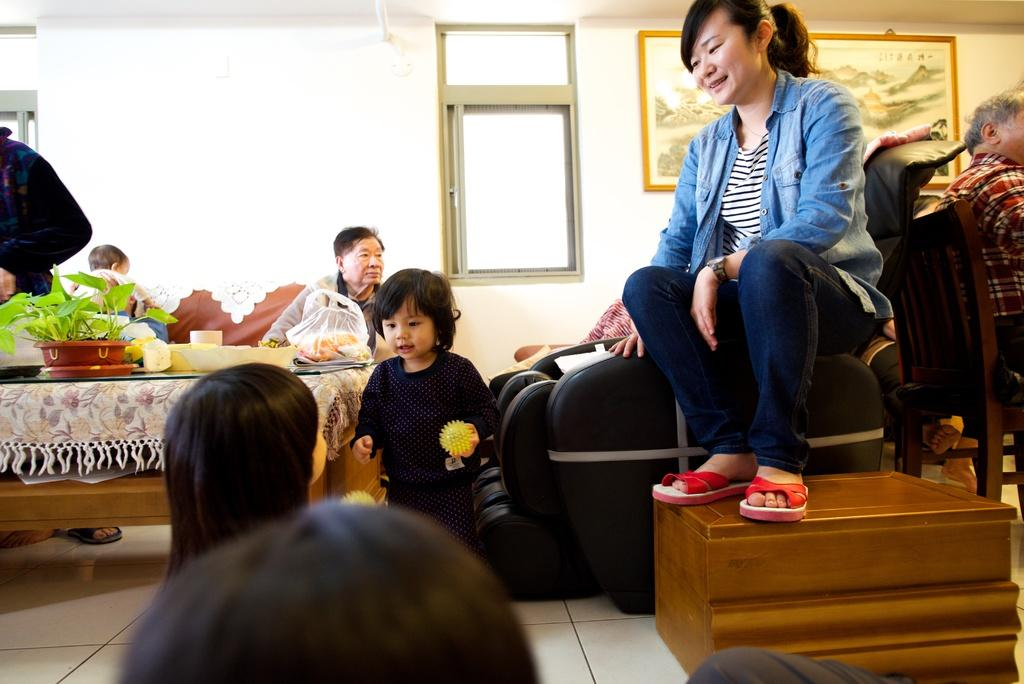What are the people in the image doing? There is a group of people sitting in the image. What is present in the image besides the people? There is a table in the image. What can be seen on the table? There is a flower vase on the table, and there are objects on the table. What is attached to the wall in the image? There are frames attached to the wall. What type of sheep can be seen grazing in the image? There are no sheep present in the image; it features a group of people sitting and other elements mentioned in the conversation. 